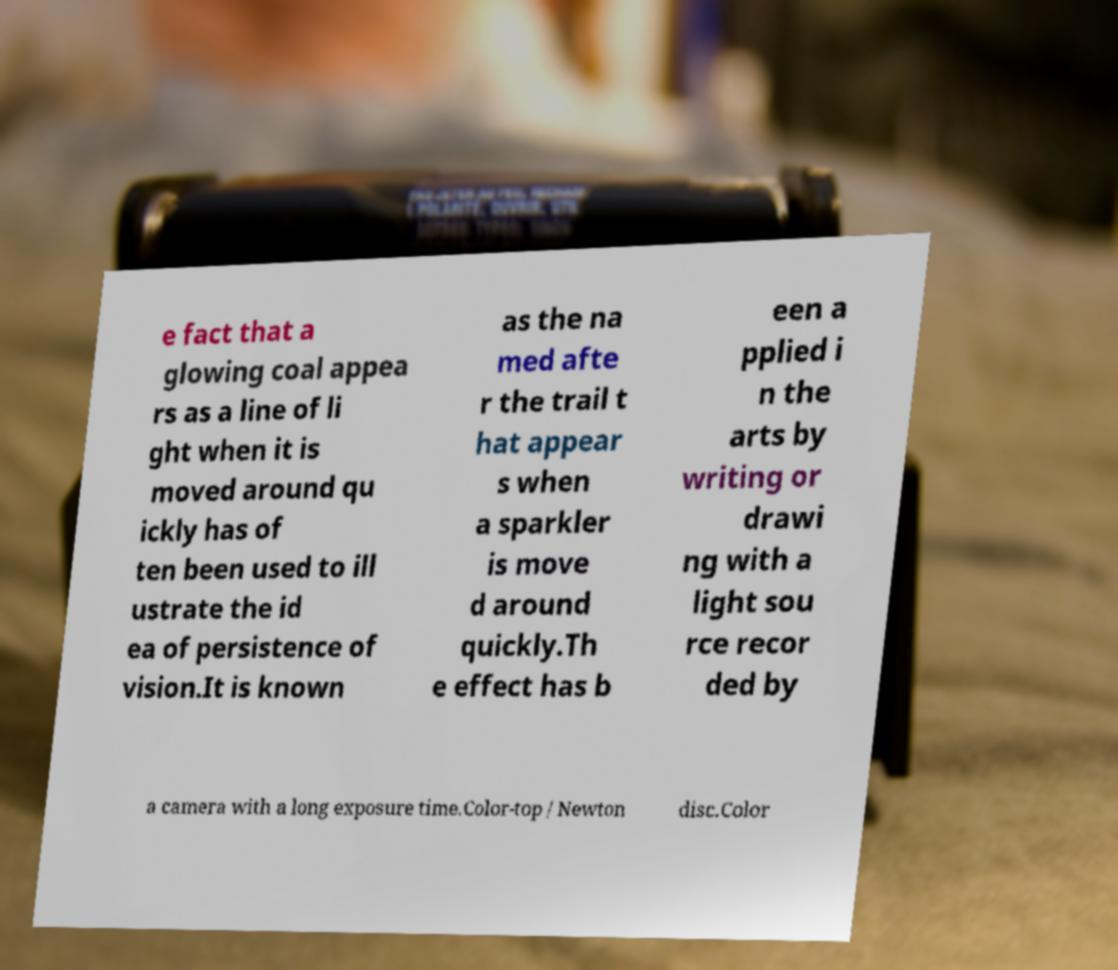I need the written content from this picture converted into text. Can you do that? e fact that a glowing coal appea rs as a line of li ght when it is moved around qu ickly has of ten been used to ill ustrate the id ea of persistence of vision.It is known as the na med afte r the trail t hat appear s when a sparkler is move d around quickly.Th e effect has b een a pplied i n the arts by writing or drawi ng with a light sou rce recor ded by a camera with a long exposure time.Color-top / Newton disc.Color 